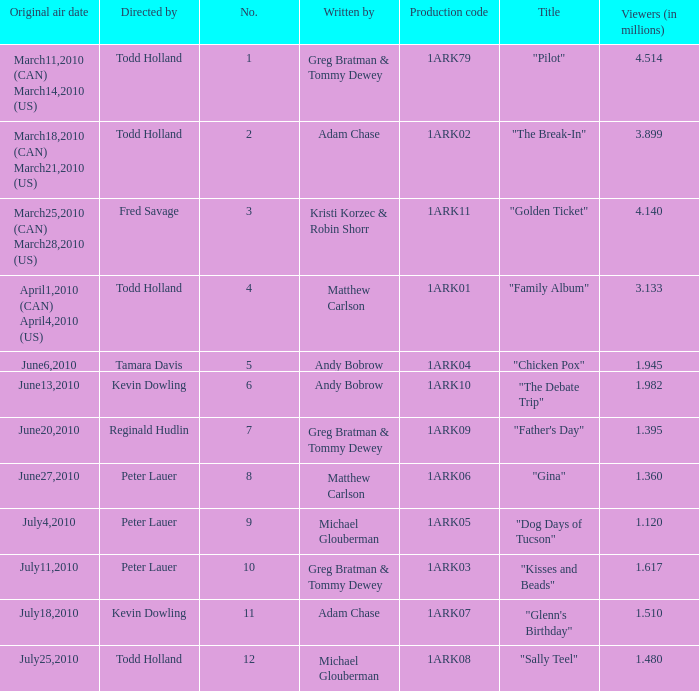List all who wrote for production code 1ark07. Adam Chase. 